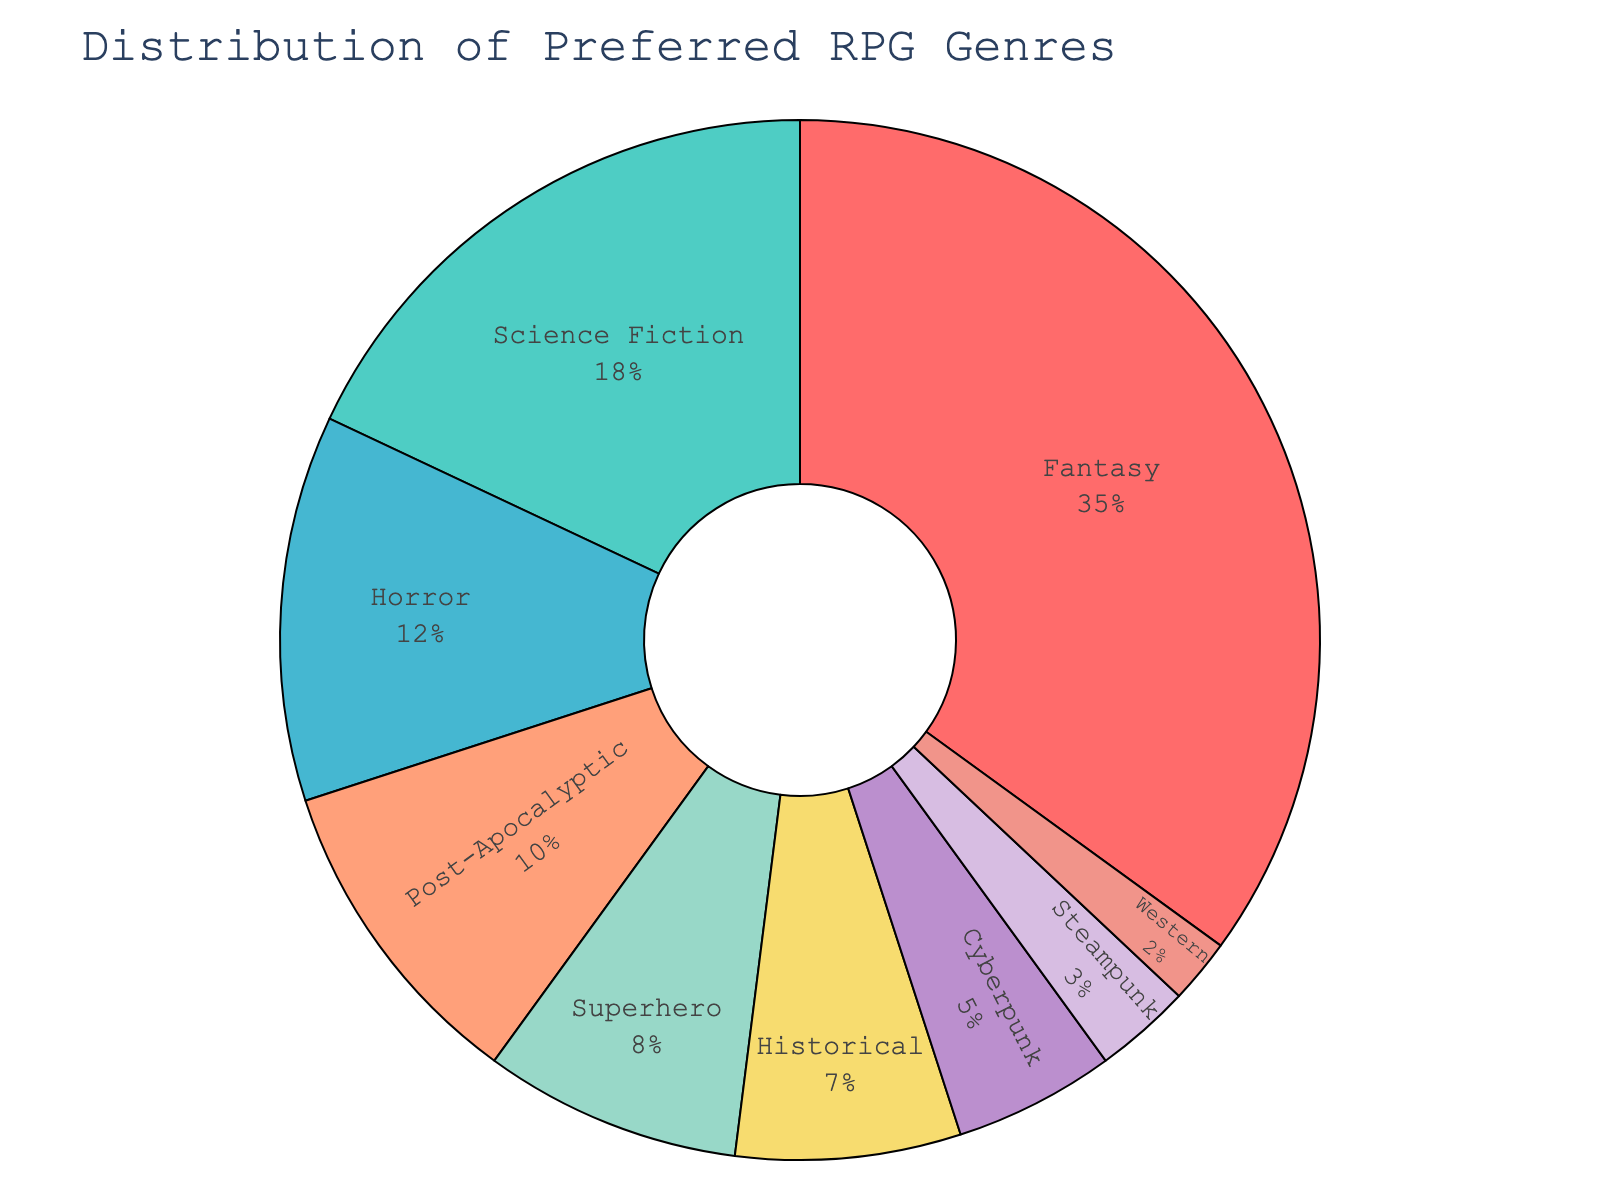Which RPG genre is the most popular among players? The figure shows that Fantasy has the largest section in the pie chart, indicating it has the highest percentage.
Answer: Fantasy What is the combined percentage of players who prefer Fantasy and Science Fiction genres? The percentages for Fantasy and Science Fiction are 35% and 18%, respectively. Adding these together gives us 35 + 18 = 53%.
Answer: 53% How does the percentage of players who prefer Horror compare to those who prefer Post-Apocalyptic genres? The figure shows Horror has a percentage of 12%, while Post-Apocalyptic has 10%. Since 12 is greater than 10, Horror is more preferred.
Answer: Horror > Post-Apocalyptic Which RPG genre has a higher preference among players: Superhero or Historical? The percentage for Superhero is 8%, and for Historical, it is 7%. Since 8 is greater than 7, Superhero is more preferred.
Answer: Superhero What is the total percentage of players who prefer Western, Steampunk, and Cyberpunk genres combined? The percentages for Western, Steampunk, and Cyberpunk are 2%, 3%, and 5%, respectively. Combining these gives 2 + 3 + 5 = 10%.
Answer: 10% What is the difference in percentage points between the Fantasy genre and the Cyberpunk genre? The percentage for Fantasy is 35%, and for Cyberpunk, it's 5%. The difference is 35 - 5 = 30 percentage points.
Answer: 30 Is the Steampunk genre less preferred than the Science Fiction genre? The pie chart shows Steampunk has a percentage of 3%, whereas Science Fiction has 18%. Since 3 is less than 18, Steampunk is less preferred.
Answer: Yes Which color represents the Horror genre on the pie chart? The pie chart uses distinct colors for each genre, and Horror is represented in a specific color. In this case, Horror is indicated by a section colored red.
Answer: Red What is the percentage of players who prefer genres other than Fantasy and Science Fiction? The percentages for Fantasy and Science Fiction are 35% and 18%, respectively. Subtracting these from 100% gives 100 - 35 - 18 = 47%.
Answer: 47% Sum the percentages for all the genres displayed in the pie chart. Does it equal 100%? Adding all the percentages from the pie chart: 35 + 18 + 12 + 10 + 8 + 7 + 5 + 3 + 2 = 100%. This confirms that the sum equals 100%.
Answer: Yes 